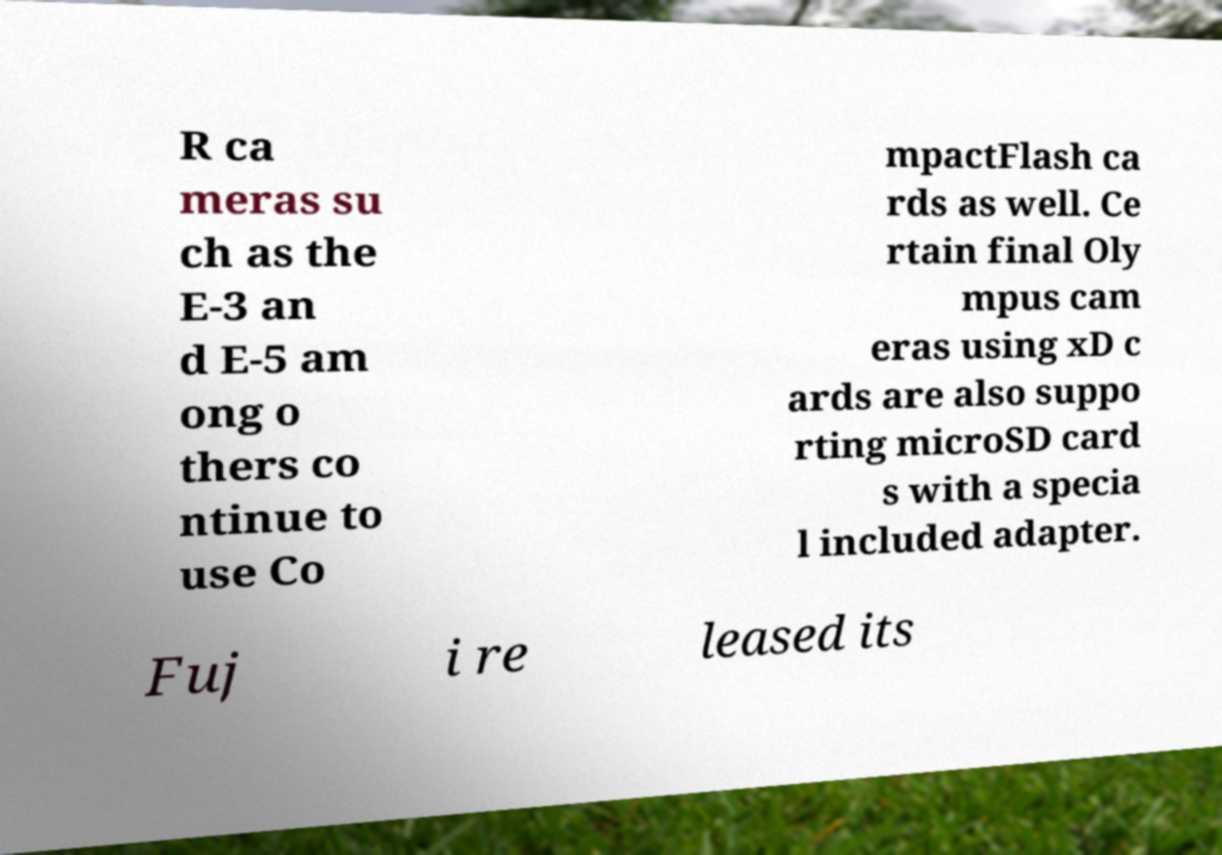There's text embedded in this image that I need extracted. Can you transcribe it verbatim? R ca meras su ch as the E-3 an d E-5 am ong o thers co ntinue to use Co mpactFlash ca rds as well. Ce rtain final Oly mpus cam eras using xD c ards are also suppo rting microSD card s with a specia l included adapter. Fuj i re leased its 